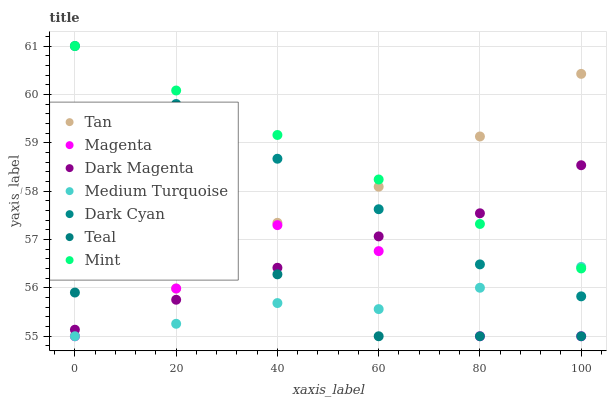Does Medium Turquoise have the minimum area under the curve?
Answer yes or no. Yes. Does Mint have the maximum area under the curve?
Answer yes or no. Yes. Does Teal have the minimum area under the curve?
Answer yes or no. No. Does Teal have the maximum area under the curve?
Answer yes or no. No. Is Mint the smoothest?
Answer yes or no. Yes. Is Magenta the roughest?
Answer yes or no. Yes. Is Teal the smoothest?
Answer yes or no. No. Is Teal the roughest?
Answer yes or no. No. Does Medium Turquoise have the lowest value?
Answer yes or no. Yes. Does Dark Cyan have the lowest value?
Answer yes or no. No. Does Mint have the highest value?
Answer yes or no. Yes. Does Teal have the highest value?
Answer yes or no. No. Is Medium Turquoise less than Tan?
Answer yes or no. Yes. Is Dark Magenta greater than Medium Turquoise?
Answer yes or no. Yes. Does Medium Turquoise intersect Magenta?
Answer yes or no. Yes. Is Medium Turquoise less than Magenta?
Answer yes or no. No. Is Medium Turquoise greater than Magenta?
Answer yes or no. No. Does Medium Turquoise intersect Tan?
Answer yes or no. No. 